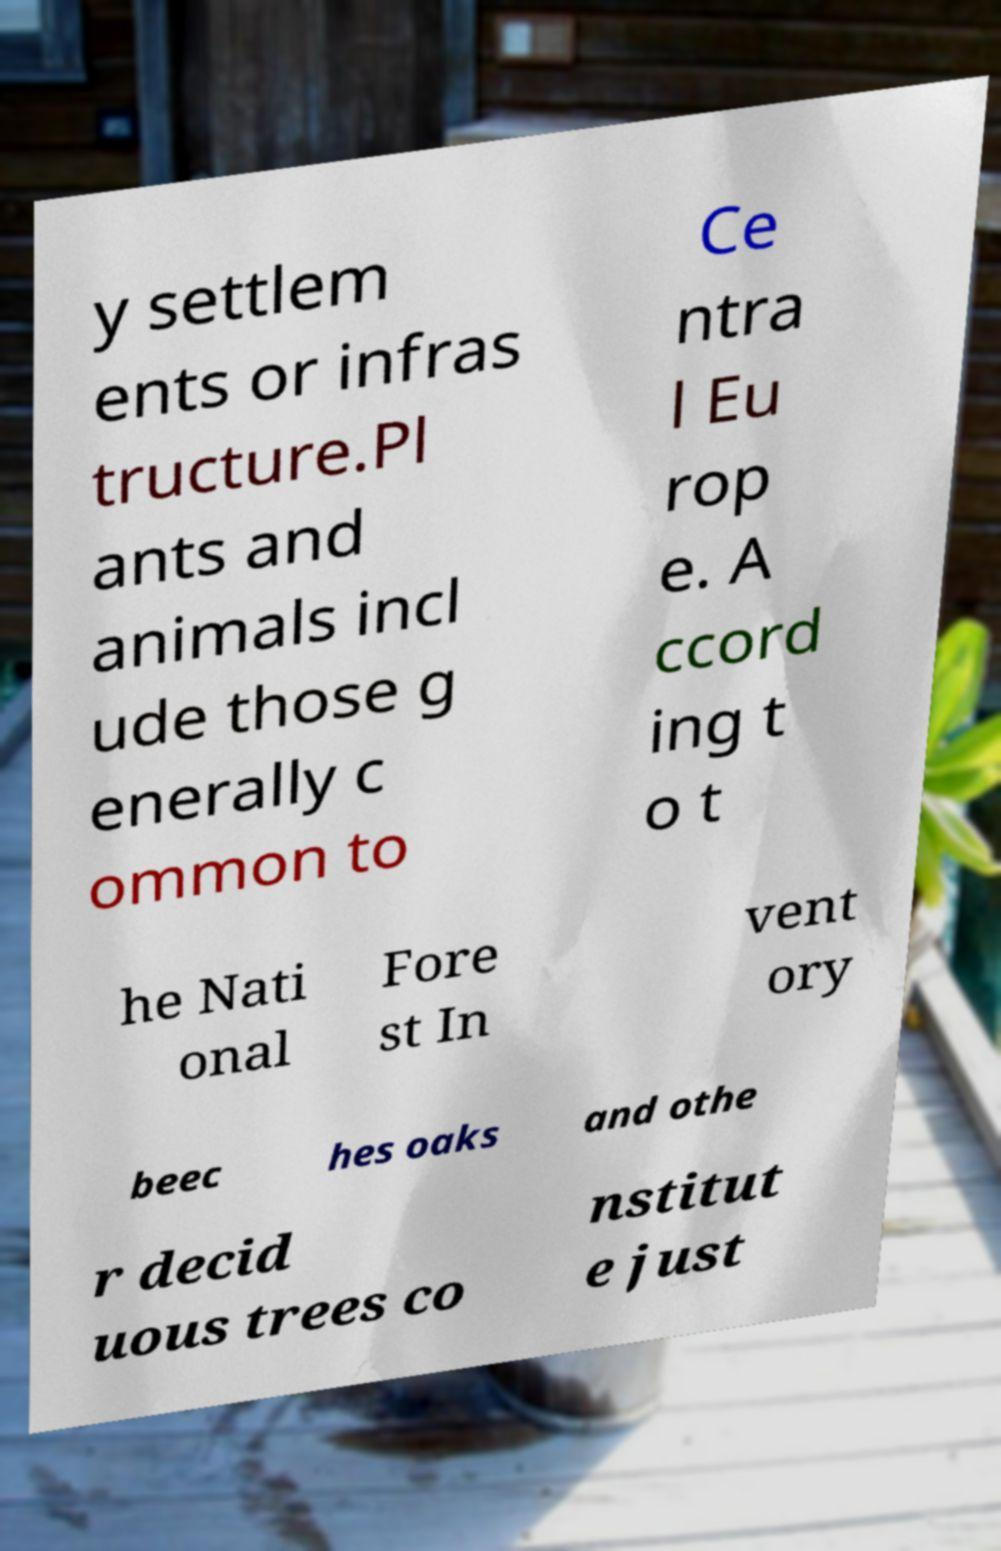What messages or text are displayed in this image? I need them in a readable, typed format. y settlem ents or infras tructure.Pl ants and animals incl ude those g enerally c ommon to Ce ntra l Eu rop e. A ccord ing t o t he Nati onal Fore st In vent ory beec hes oaks and othe r decid uous trees co nstitut e just 